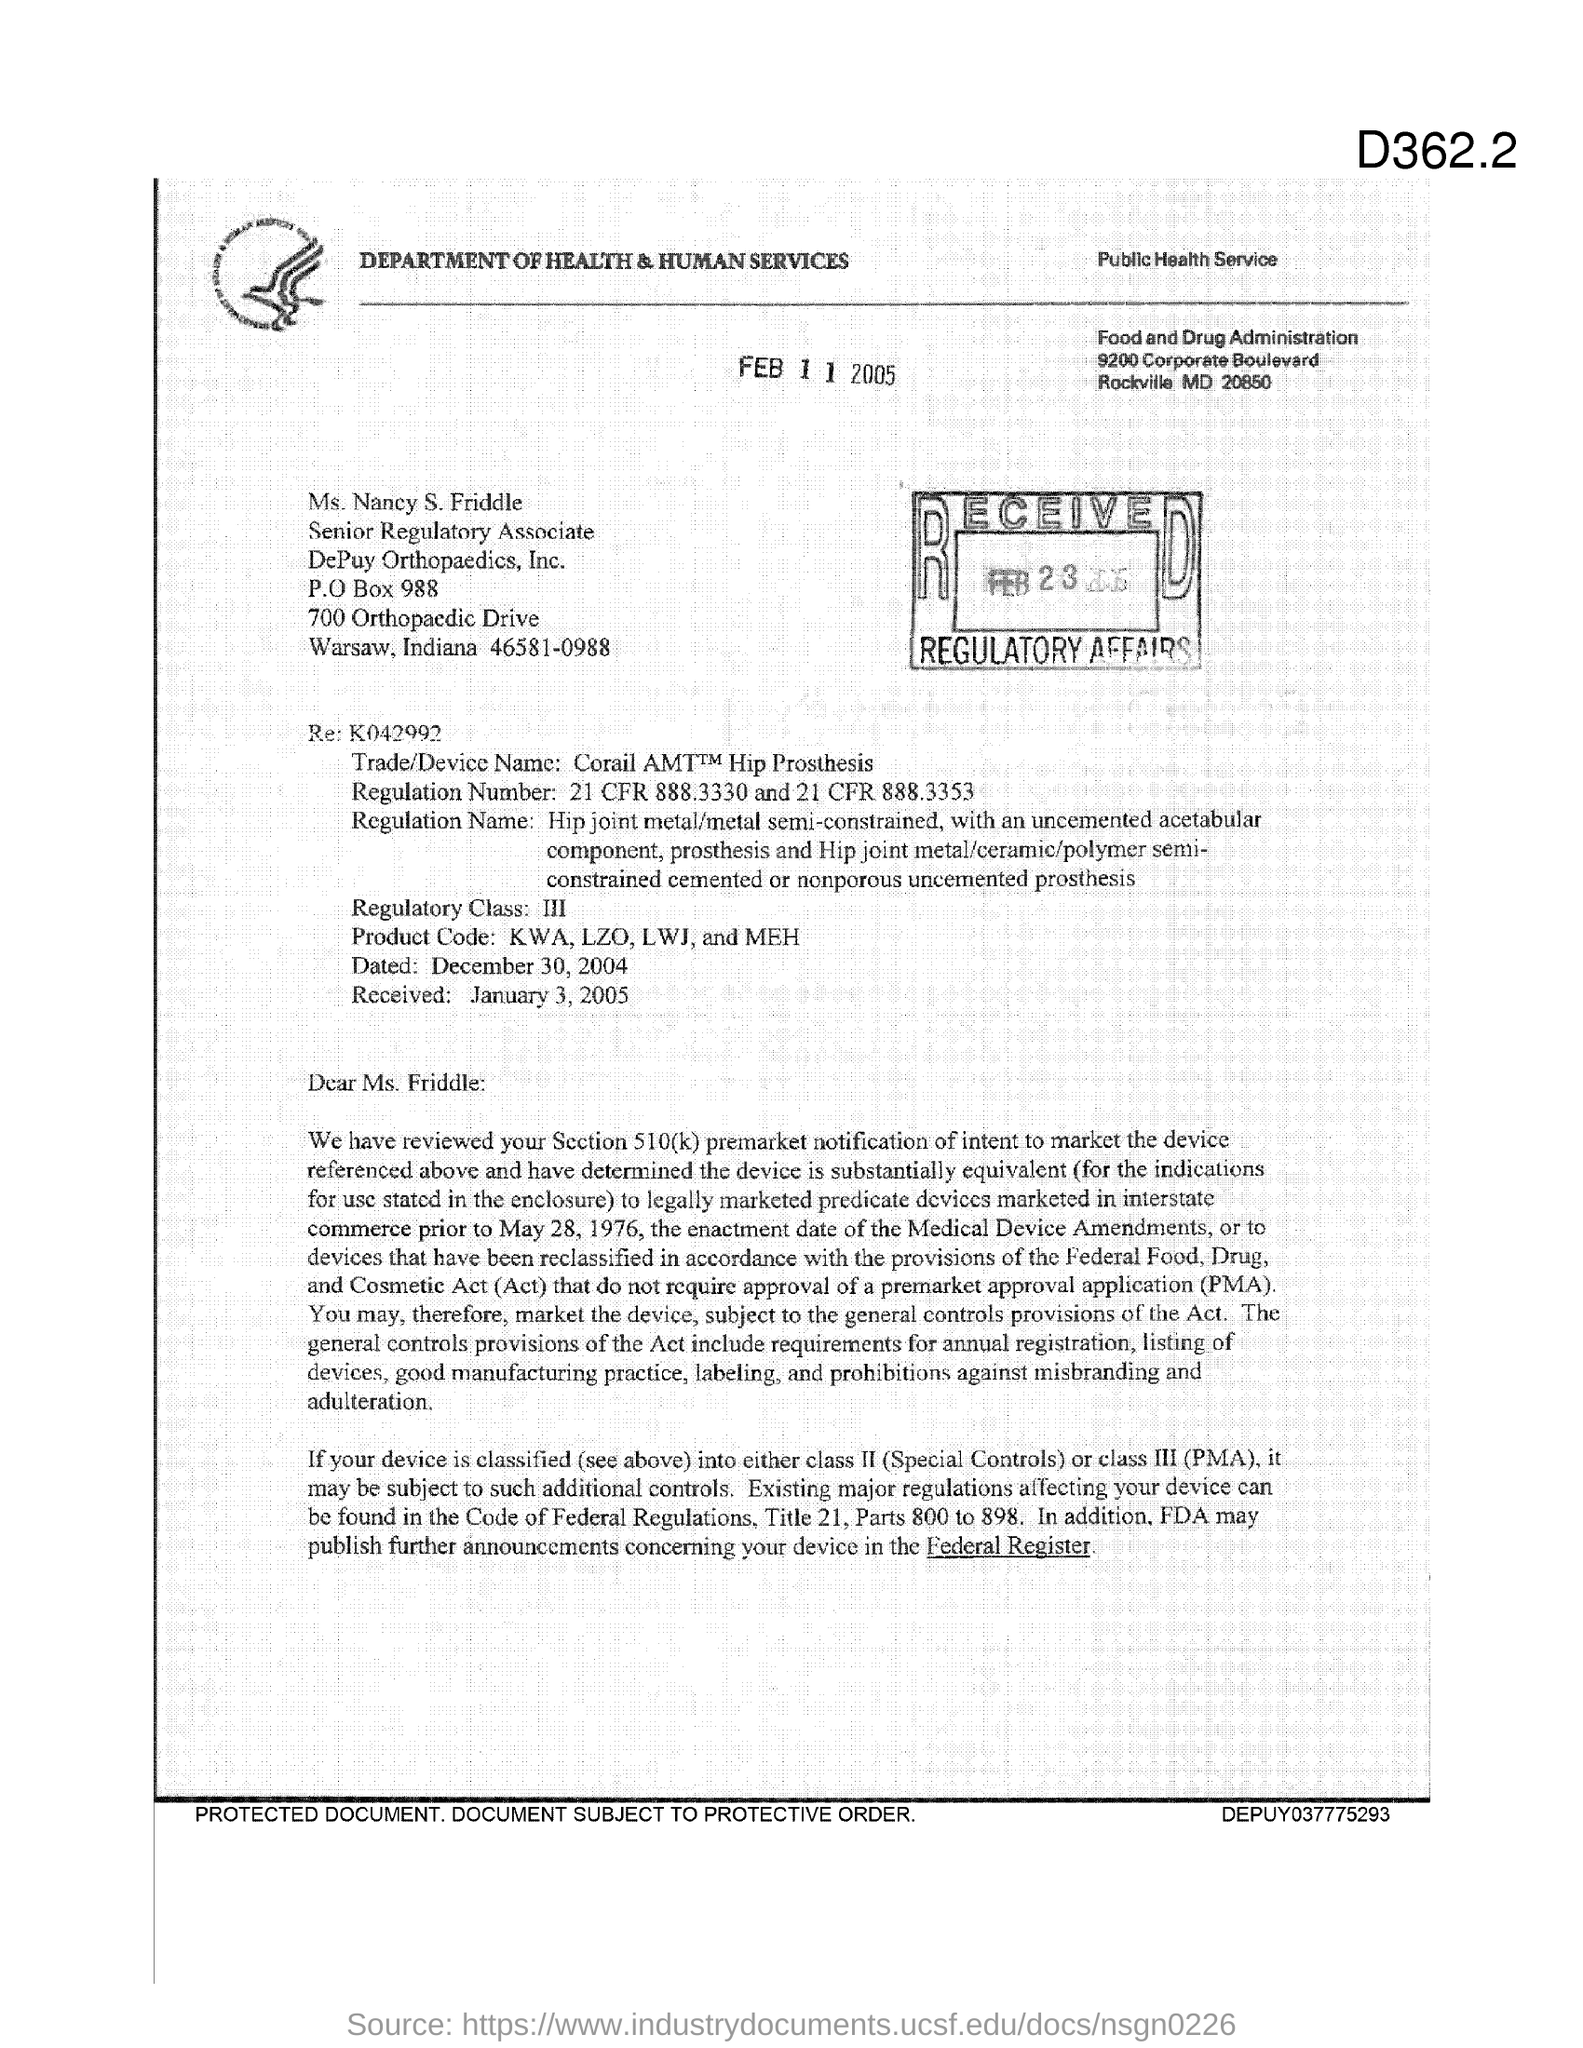In which state is depuy orthopaedics, inc. located?
Keep it short and to the point. Indiana. What is the po box no. of depuy orthopaedics, inc ?
Your answer should be compact. 988. What is the position of ms. nancy s. friddle ?
Keep it short and to the point. Senior Regulatory Associate. In which state is food and drug administration at?
Your answer should be compact. MD. What is the regulatory class?
Provide a short and direct response. III. 